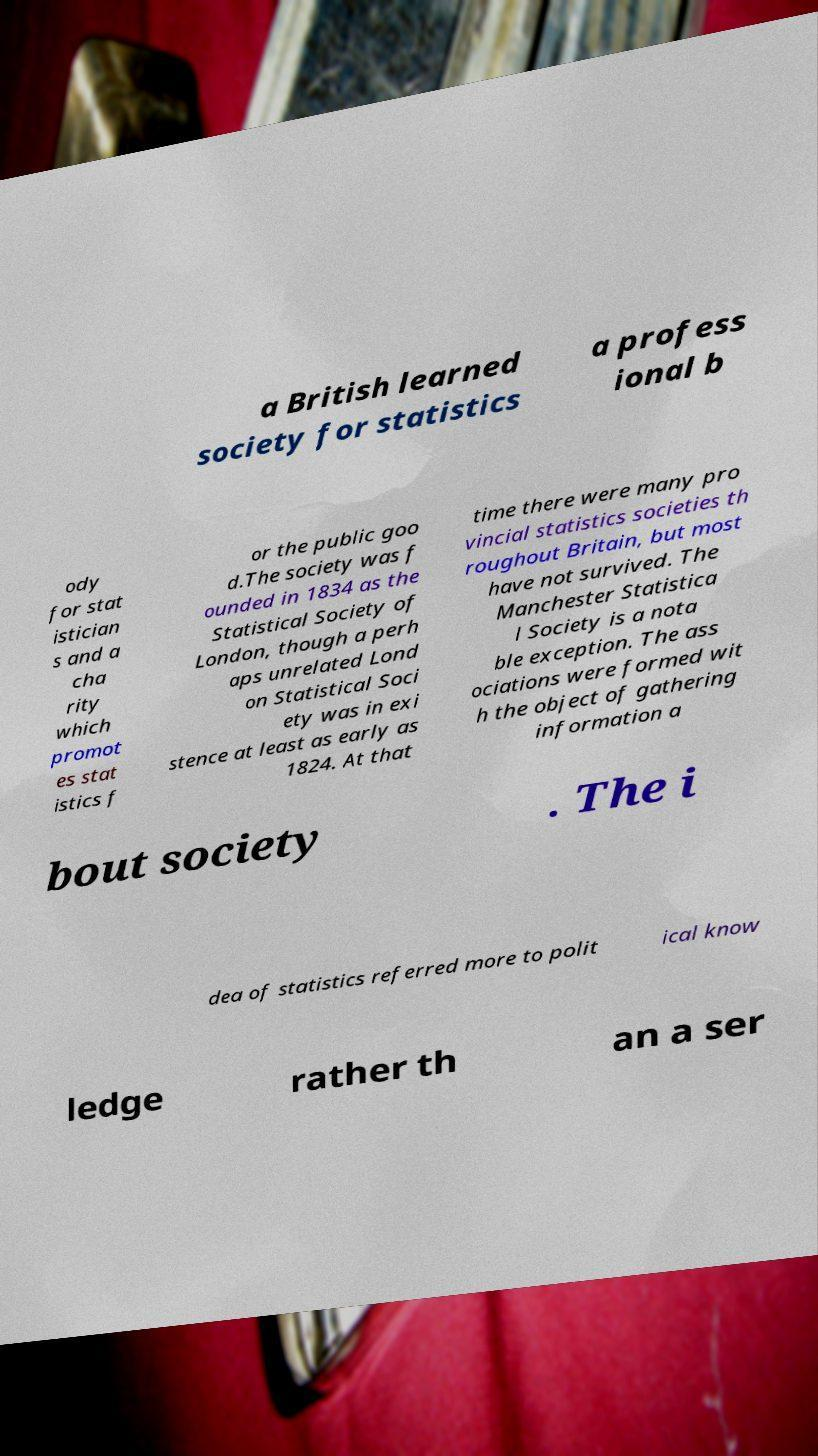Can you accurately transcribe the text from the provided image for me? a British learned society for statistics a profess ional b ody for stat istician s and a cha rity which promot es stat istics f or the public goo d.The society was f ounded in 1834 as the Statistical Society of London, though a perh aps unrelated Lond on Statistical Soci ety was in exi stence at least as early as 1824. At that time there were many pro vincial statistics societies th roughout Britain, but most have not survived. The Manchester Statistica l Society is a nota ble exception. The ass ociations were formed wit h the object of gathering information a bout society . The i dea of statistics referred more to polit ical know ledge rather th an a ser 